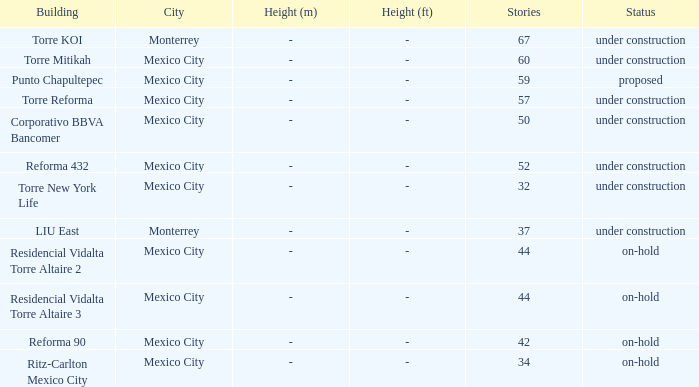What is the count of stories in the torre reforma building? 1.0. 